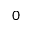<formula> <loc_0><loc_0><loc_500><loc_500>0</formula> 